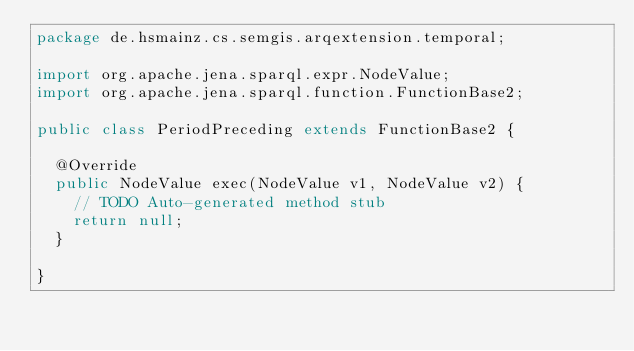<code> <loc_0><loc_0><loc_500><loc_500><_Java_>package de.hsmainz.cs.semgis.arqextension.temporal;

import org.apache.jena.sparql.expr.NodeValue;
import org.apache.jena.sparql.function.FunctionBase2;

public class PeriodPreceding extends FunctionBase2 {

	@Override
	public NodeValue exec(NodeValue v1, NodeValue v2) {
		// TODO Auto-generated method stub
		return null;
	}

}
</code> 